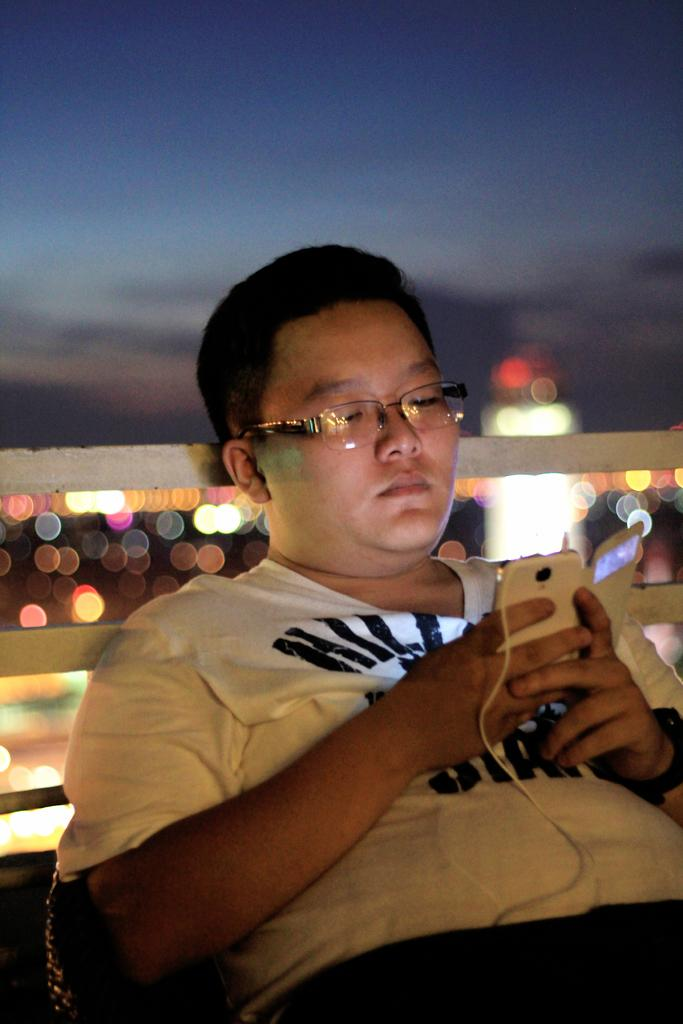What is the person in the image doing? The person is operating a mobile. What is the person wearing in the image? The person is wearing a white shirt. What is the person's position in the image? The person is sitting in a chair. What can be seen on the person's back in the image? There is a white rod on the person's back. What type of bird is perched on the person's shoulder in the image? There is no bird present in the image. 